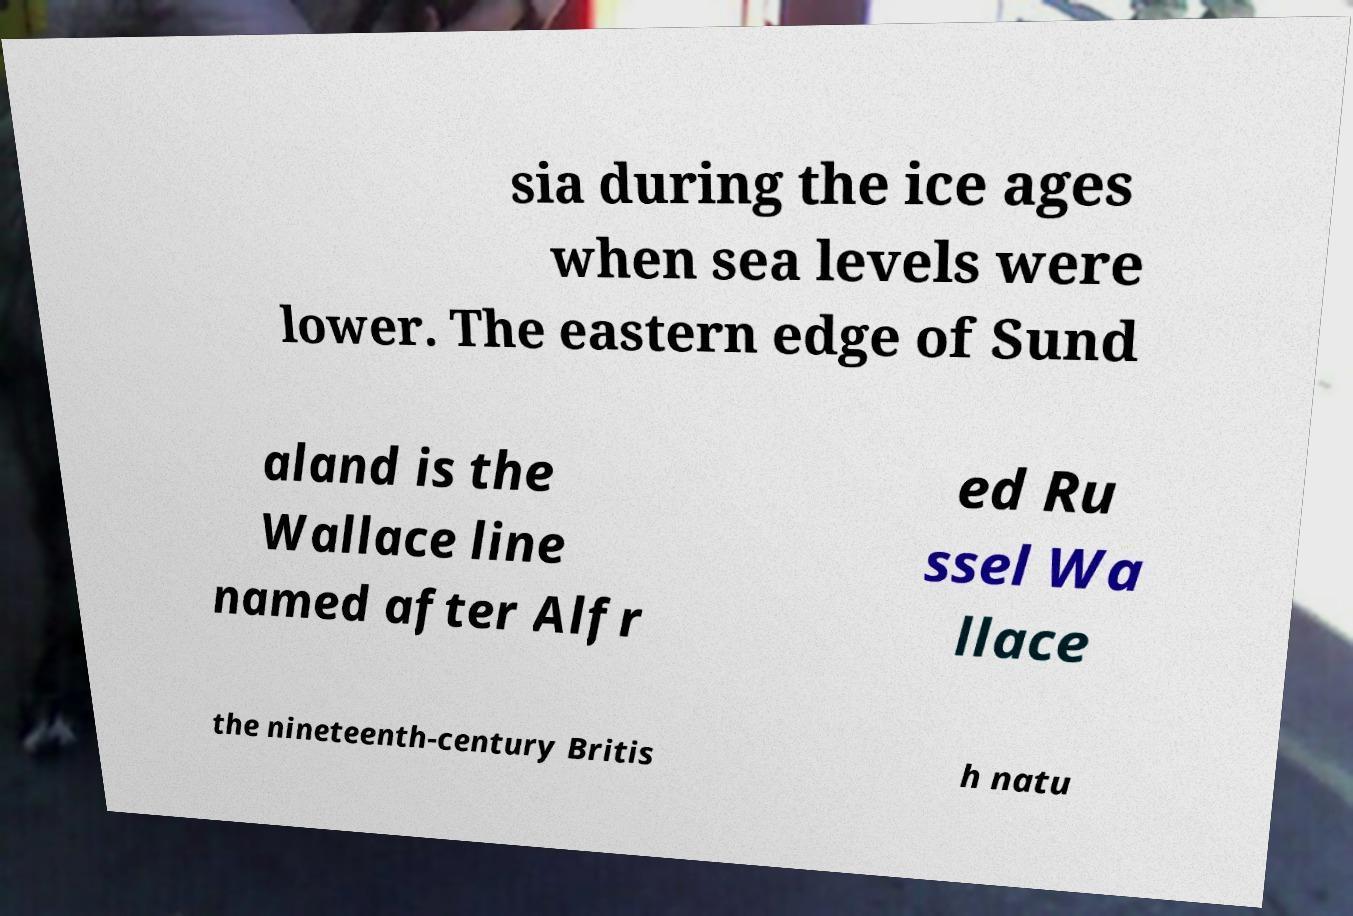Please read and relay the text visible in this image. What does it say? sia during the ice ages when sea levels were lower. The eastern edge of Sund aland is the Wallace line named after Alfr ed Ru ssel Wa llace the nineteenth-century Britis h natu 